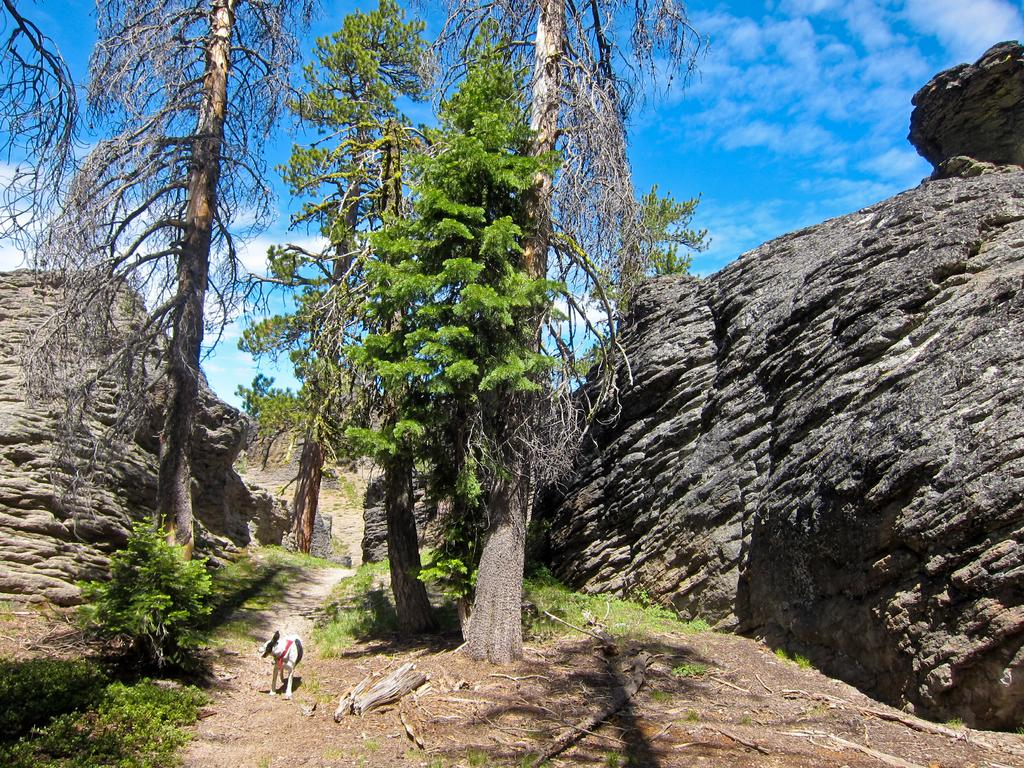What type of animal can be seen in the image? There is a dog in the image. What is located at the bottom of the image? There are plants at the bottom of the image. What can be found in the middle of the image? Rocks and trees are present in the middle of the image. How would you describe the sky in the background of the image? The sky is cloudy in the background of the image. What theory is the dog trying to prove in the image? There is no theory present in the image; it is a dog in a natural setting with plants, rocks, trees, and a cloudy sky. 